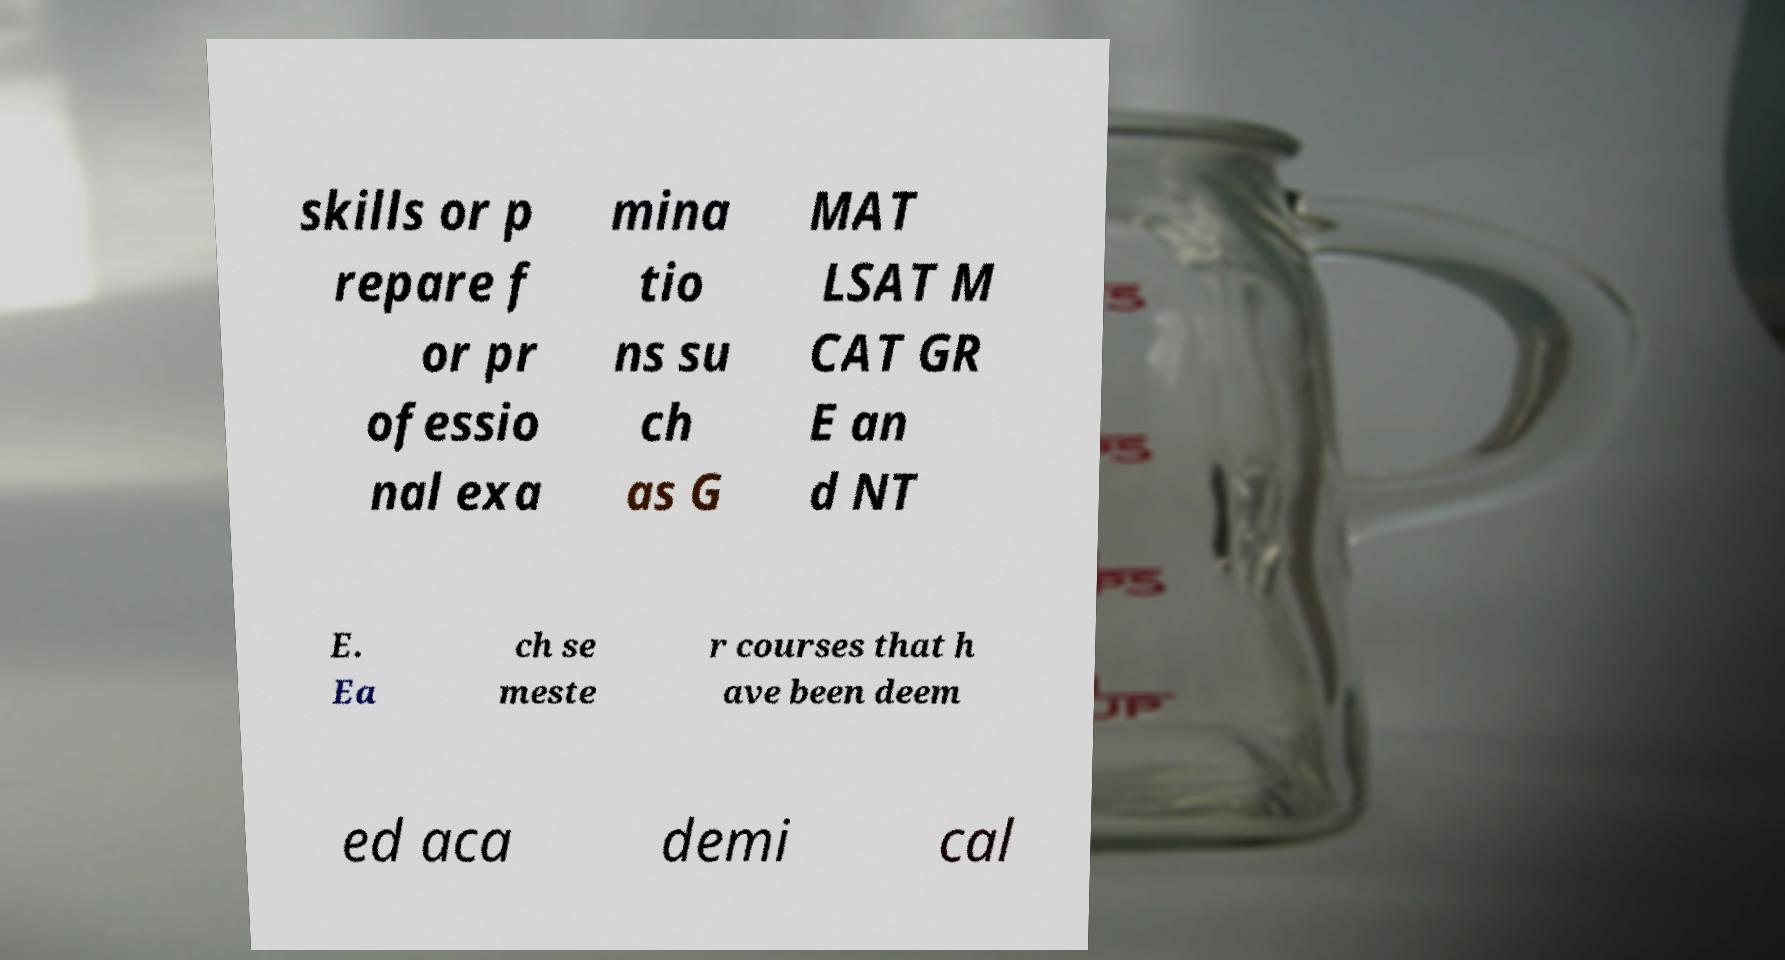I need the written content from this picture converted into text. Can you do that? skills or p repare f or pr ofessio nal exa mina tio ns su ch as G MAT LSAT M CAT GR E an d NT E. Ea ch se meste r courses that h ave been deem ed aca demi cal 